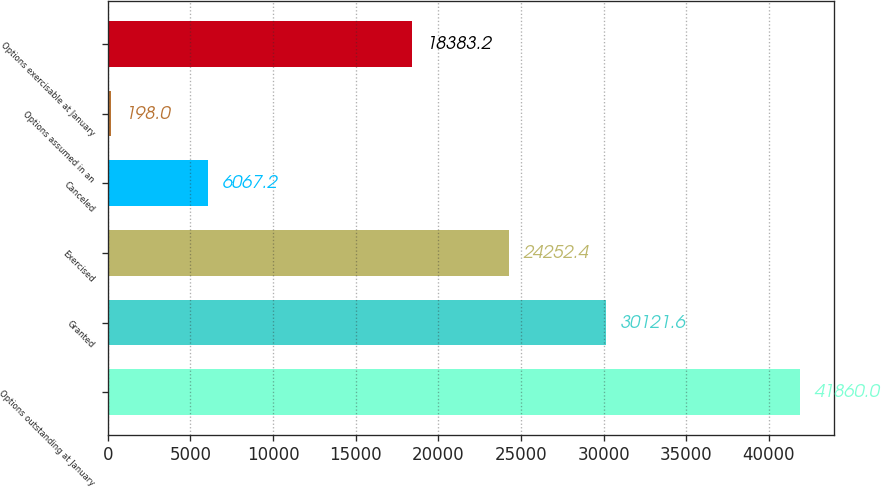Convert chart to OTSL. <chart><loc_0><loc_0><loc_500><loc_500><bar_chart><fcel>Options outstanding at January<fcel>Granted<fcel>Exercised<fcel>Canceled<fcel>Options assumed in an<fcel>Options exercisable at January<nl><fcel>41860<fcel>30121.6<fcel>24252.4<fcel>6067.2<fcel>198<fcel>18383.2<nl></chart> 